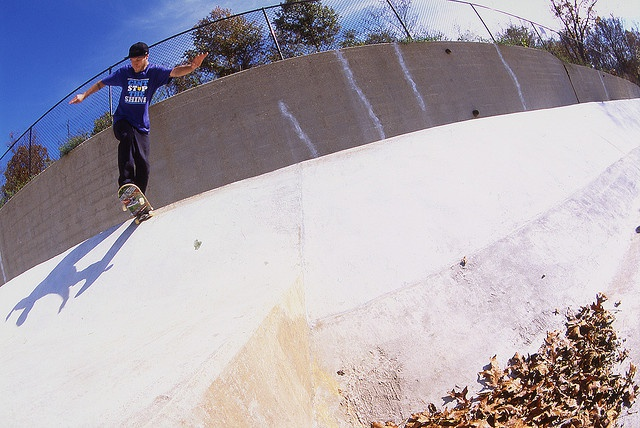Describe the objects in this image and their specific colors. I can see people in blue, black, navy, gray, and brown tones and skateboard in blue, gray, black, and darkgreen tones in this image. 